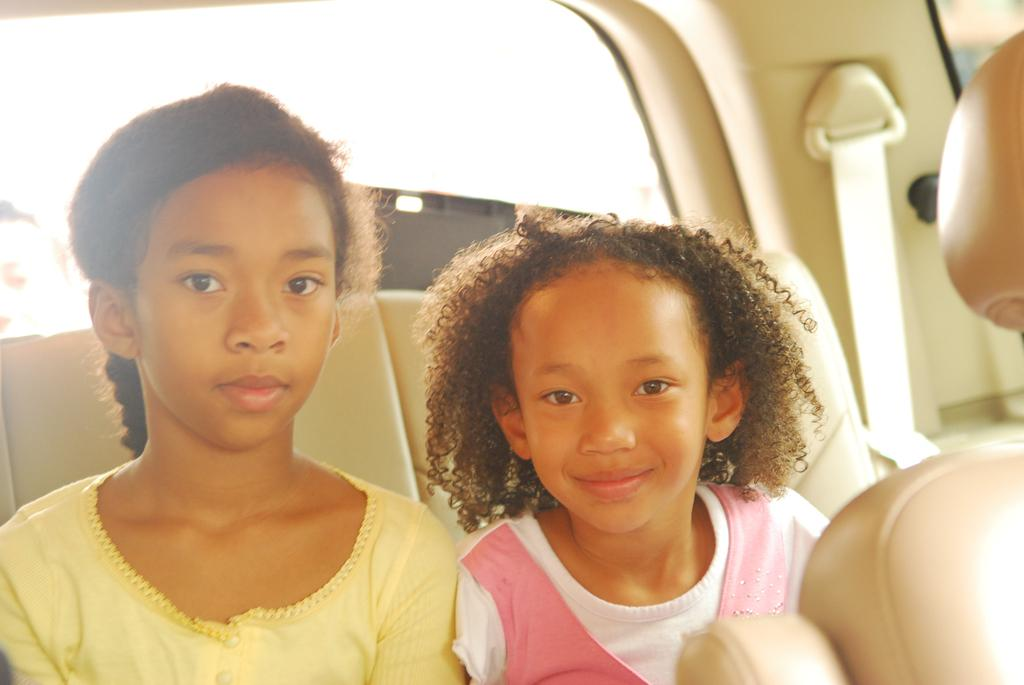How many people are in the image? There are two girls in the image. Where are the girls located in the image? The girls are in the center of the image. What is the setting of the image? The girls are in a car. What type of power source is used to operate the car in the image? The image does not provide information about the power source of the car. How many cakes are visible in the image? There are no cakes present in the image. 